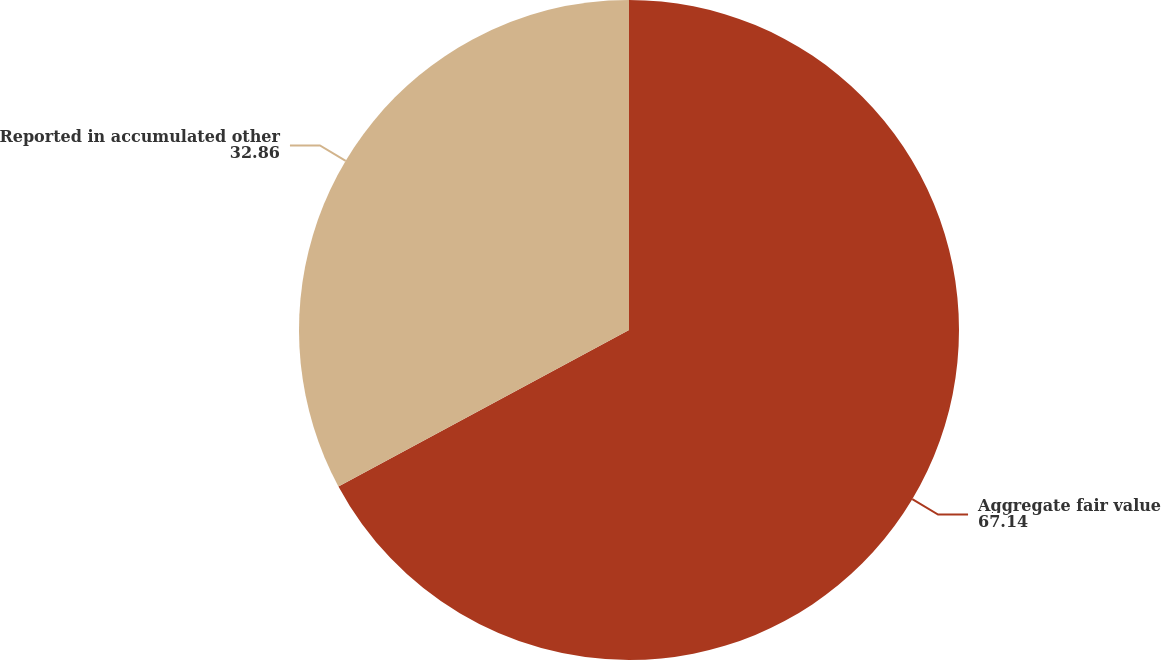Convert chart to OTSL. <chart><loc_0><loc_0><loc_500><loc_500><pie_chart><fcel>Aggregate fair value<fcel>Reported in accumulated other<nl><fcel>67.14%<fcel>32.86%<nl></chart> 